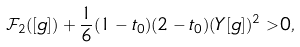<formula> <loc_0><loc_0><loc_500><loc_500>\mathcal { F } _ { 2 } ( [ g ] ) + \frac { 1 } { 6 } ( 1 - t _ { 0 } ) ( 2 - t _ { 0 } ) ( Y [ g ] ) ^ { 2 } > 0 ,</formula> 